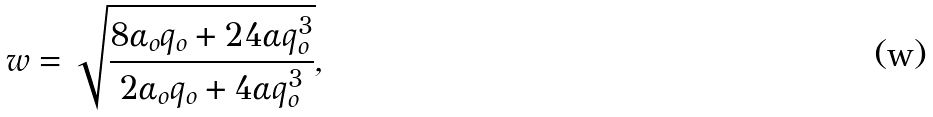Convert formula to latex. <formula><loc_0><loc_0><loc_500><loc_500>w = \sqrt { \frac { 8 \alpha _ { o } q _ { o } + 2 4 \alpha q _ { o } ^ { 3 } } { 2 \alpha _ { o } q _ { o } + 4 \alpha q _ { o } ^ { 3 } } } ,</formula> 